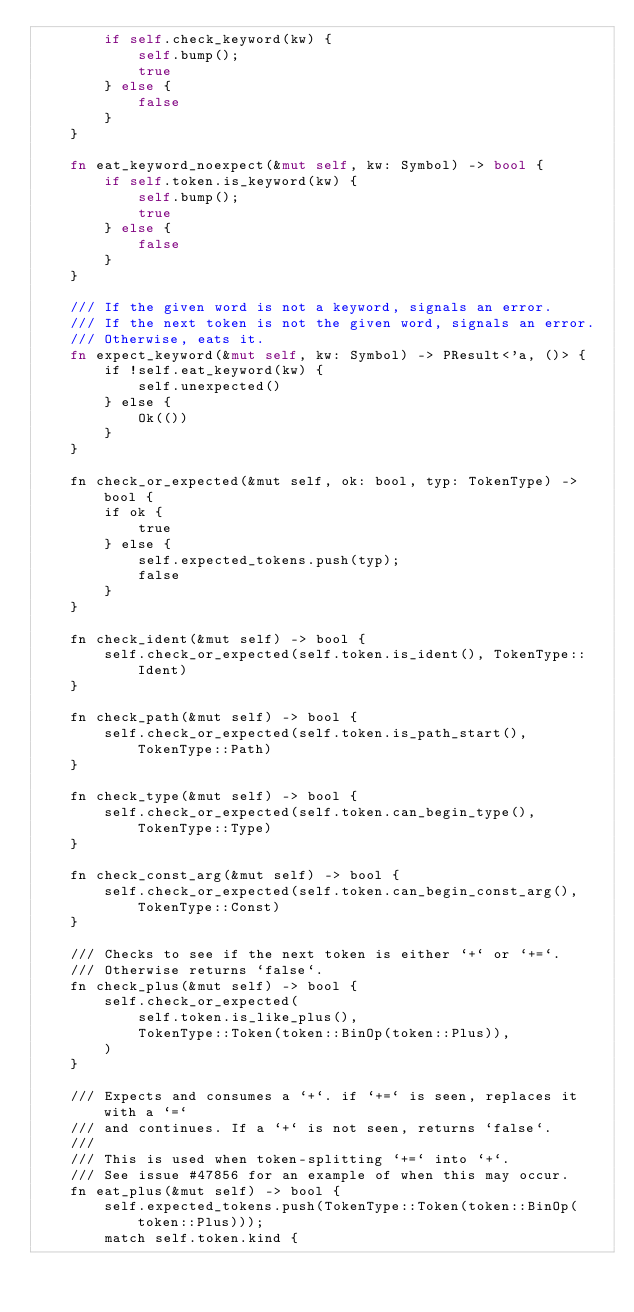Convert code to text. <code><loc_0><loc_0><loc_500><loc_500><_Rust_>        if self.check_keyword(kw) {
            self.bump();
            true
        } else {
            false
        }
    }

    fn eat_keyword_noexpect(&mut self, kw: Symbol) -> bool {
        if self.token.is_keyword(kw) {
            self.bump();
            true
        } else {
            false
        }
    }

    /// If the given word is not a keyword, signals an error.
    /// If the next token is not the given word, signals an error.
    /// Otherwise, eats it.
    fn expect_keyword(&mut self, kw: Symbol) -> PResult<'a, ()> {
        if !self.eat_keyword(kw) {
            self.unexpected()
        } else {
            Ok(())
        }
    }

    fn check_or_expected(&mut self, ok: bool, typ: TokenType) -> bool {
        if ok {
            true
        } else {
            self.expected_tokens.push(typ);
            false
        }
    }

    fn check_ident(&mut self) -> bool {
        self.check_or_expected(self.token.is_ident(), TokenType::Ident)
    }

    fn check_path(&mut self) -> bool {
        self.check_or_expected(self.token.is_path_start(), TokenType::Path)
    }

    fn check_type(&mut self) -> bool {
        self.check_or_expected(self.token.can_begin_type(), TokenType::Type)
    }

    fn check_const_arg(&mut self) -> bool {
        self.check_or_expected(self.token.can_begin_const_arg(), TokenType::Const)
    }

    /// Checks to see if the next token is either `+` or `+=`.
    /// Otherwise returns `false`.
    fn check_plus(&mut self) -> bool {
        self.check_or_expected(
            self.token.is_like_plus(),
            TokenType::Token(token::BinOp(token::Plus)),
        )
    }

    /// Expects and consumes a `+`. if `+=` is seen, replaces it with a `=`
    /// and continues. If a `+` is not seen, returns `false`.
    ///
    /// This is used when token-splitting `+=` into `+`.
    /// See issue #47856 for an example of when this may occur.
    fn eat_plus(&mut self) -> bool {
        self.expected_tokens.push(TokenType::Token(token::BinOp(token::Plus)));
        match self.token.kind {</code> 